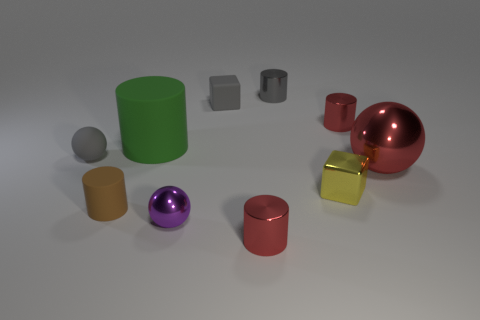Subtract all brown cylinders. Subtract all green spheres. How many cylinders are left? 4 Subtract all brown balls. How many gray blocks are left? 1 Add 2 tiny objects. How many tiny reds exist? 0 Subtract all small gray balls. Subtract all large red spheres. How many objects are left? 8 Add 4 big red shiny spheres. How many big red shiny spheres are left? 5 Add 8 yellow shiny blocks. How many yellow shiny blocks exist? 9 Subtract all red cylinders. How many cylinders are left? 3 Subtract all matte spheres. How many spheres are left? 2 Subtract 0 cyan cylinders. How many objects are left? 10 Subtract all cubes. How many objects are left? 8 